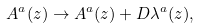<formula> <loc_0><loc_0><loc_500><loc_500>A ^ { a } ( z ) \rightarrow A ^ { a } ( z ) + D \lambda ^ { a } ( z ) ,</formula> 